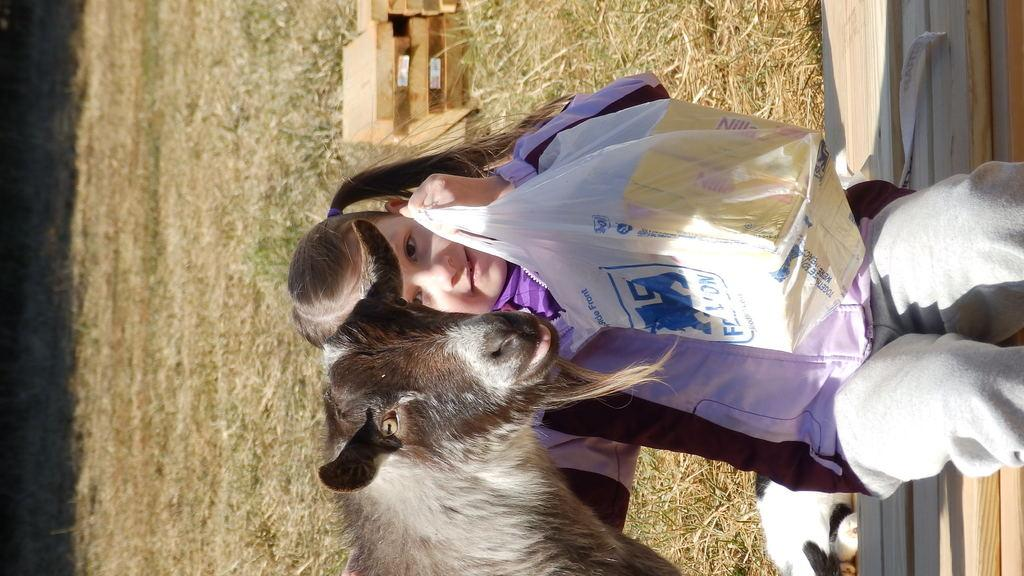What is the girl doing in the image? The girl is sitting on a bench in the image. What is located near the girl? There is a cover with boxes in the image. What type of animal can be seen in the image? An animal is visible in the image. What can be seen in the background of the image? There is grass and boxes in the background of the image. How many kittens are sitting on the table in the image? There is no table present in the image, and therefore no kittens can be found on it. 